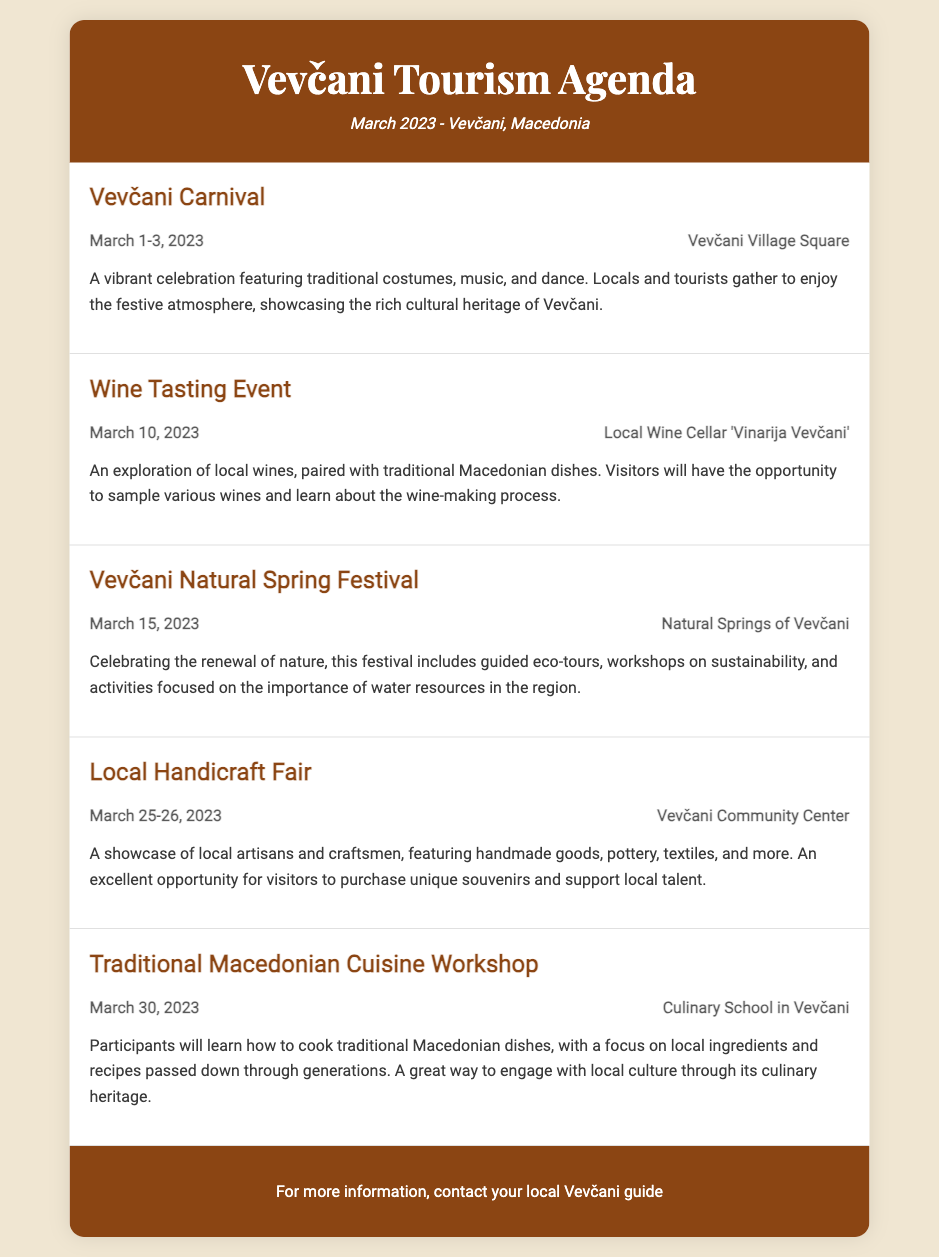What are the dates for the Vevčani Carnival? The Vevčani Carnival takes place from March 1 to March 3, 2023.
Answer: March 1-3, 2023 Where is the Wine Tasting Event held? The Wine Tasting Event is held at the Local Wine Cellar 'Vinarija Vevčani'.
Answer: Local Wine Cellar 'Vinarija Vevčani' What type of festival is held on March 15? The event held on March 15 is the Vevčani Natural Spring Festival.
Answer: Vevčani Natural Spring Festival How many days does the Local Handicraft Fair last? The Local Handicraft Fair lasts for two days, from March 25 to March 26.
Answer: Two days What is the focus of the Traditional Macedonian Cuisine Workshop? The focus of the workshop is on cooking traditional Macedonian dishes with local ingredients.
Answer: Traditional Macedonian dishes Which event occurs closest to the end of March? The event that occurs closest to the end of March is the Traditional Macedonian Cuisine Workshop on March 30.
Answer: Traditional Macedonian Cuisine Workshop What kind of goods are showcased at the Local Handicraft Fair? The Local Handicraft Fair showcases handmade goods, pottery, textiles, and more.
Answer: Handmade goods, pottery, textiles How many main events are listed in the agenda? The agenda lists a total of five main events.
Answer: Five 